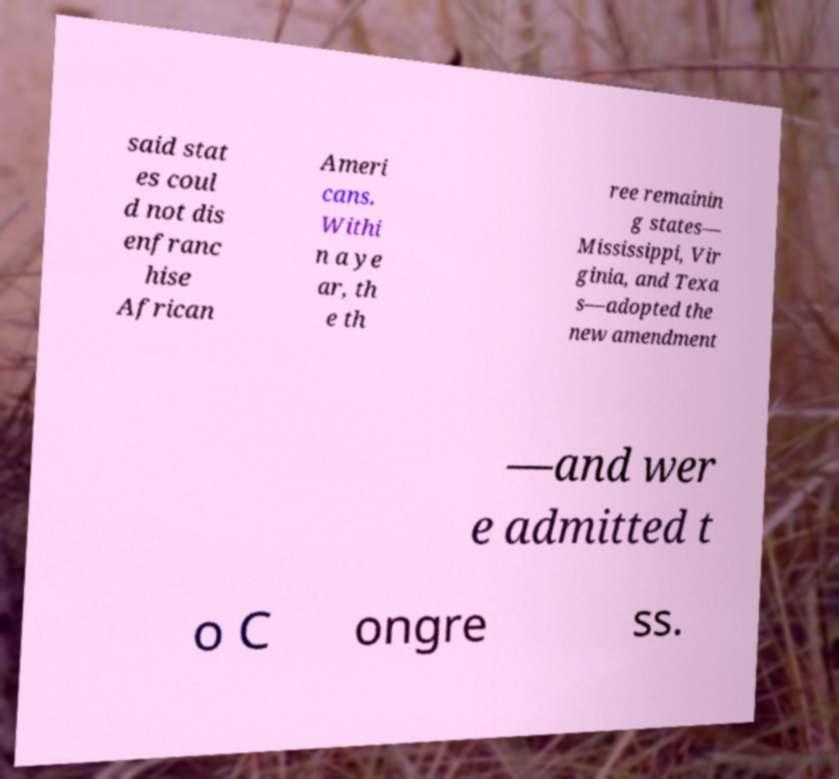What messages or text are displayed in this image? I need them in a readable, typed format. said stat es coul d not dis enfranc hise African Ameri cans. Withi n a ye ar, th e th ree remainin g states— Mississippi, Vir ginia, and Texa s—adopted the new amendment —and wer e admitted t o C ongre ss. 